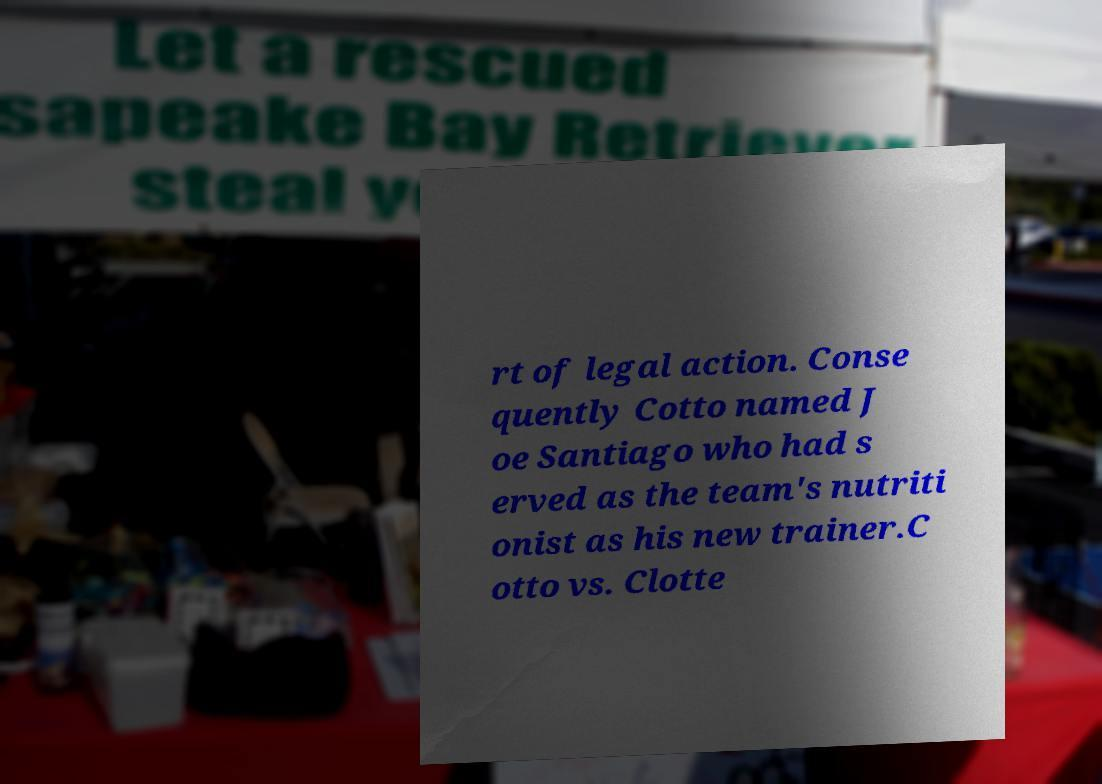Please read and relay the text visible in this image. What does it say? rt of legal action. Conse quently Cotto named J oe Santiago who had s erved as the team's nutriti onist as his new trainer.C otto vs. Clotte 